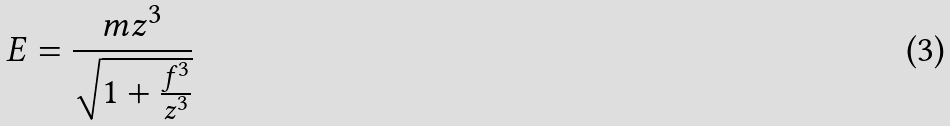<formula> <loc_0><loc_0><loc_500><loc_500>E = \frac { m z ^ { 3 } } { \sqrt { 1 + \frac { f ^ { 3 } } { z ^ { 3 } } } }</formula> 